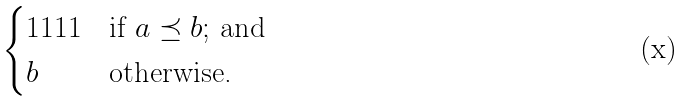Convert formula to latex. <formula><loc_0><loc_0><loc_500><loc_500>\begin{cases} 1 1 1 1 & \text {if $a\preceq b$; and} \\ b & \text {otherwise.} \end{cases}</formula> 